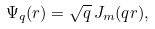Convert formula to latex. <formula><loc_0><loc_0><loc_500><loc_500>\Psi _ { q } ( r ) = \sqrt { q } \, J _ { m } ( q r ) ,</formula> 